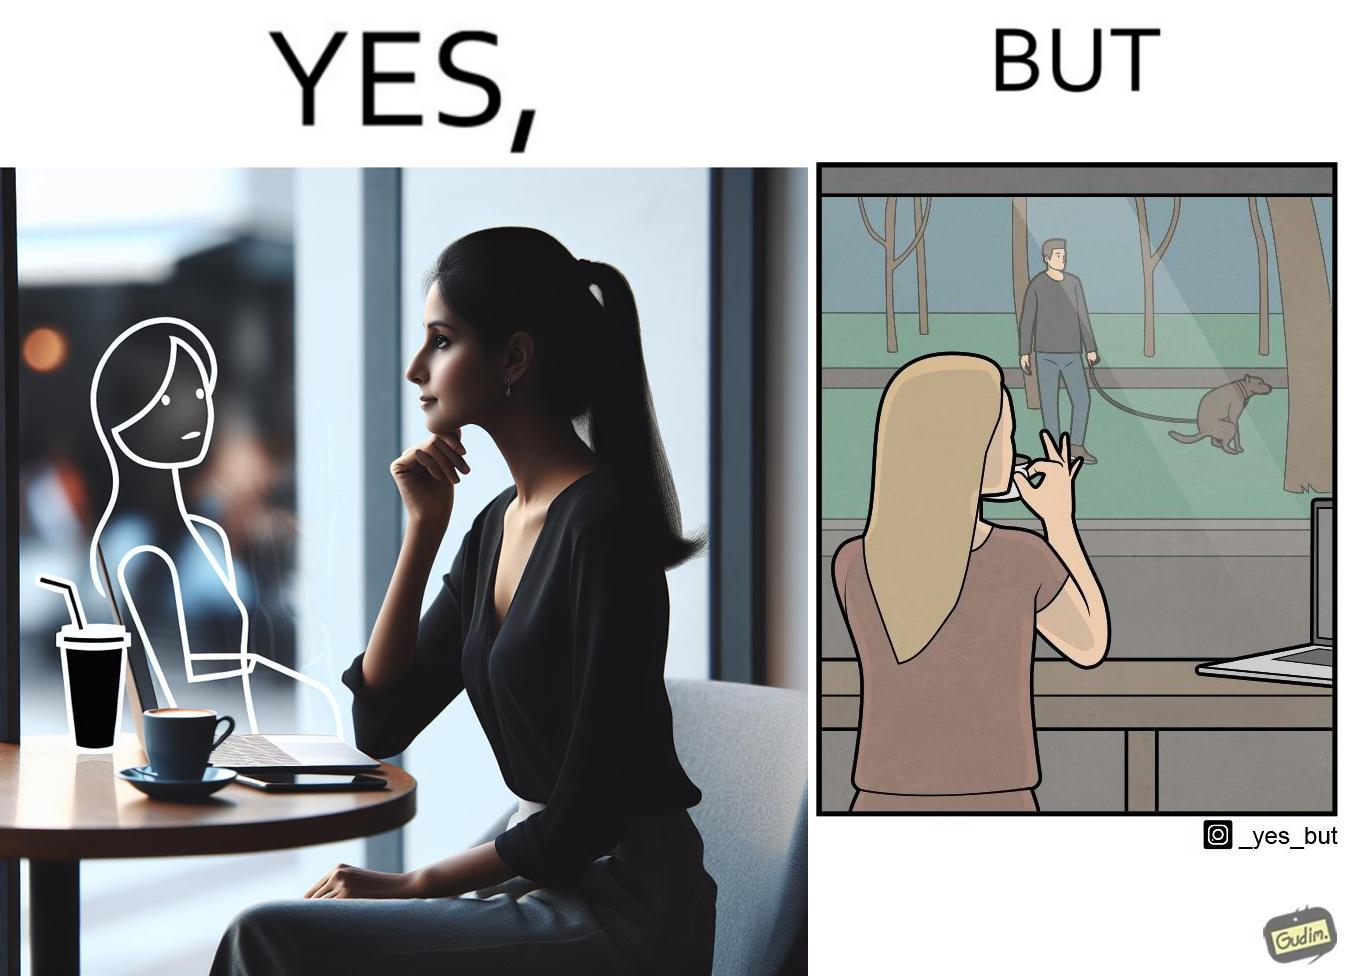Provide a description of this image. The image is ironic, because in the first image the woman is seen as enjoying the view but in the second image the same woman is seen as looking at a pooping dog 